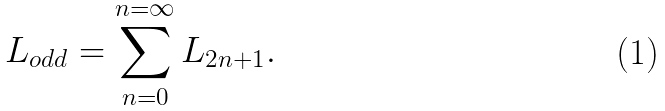Convert formula to latex. <formula><loc_0><loc_0><loc_500><loc_500>L _ { o d d } = \sum _ { n = 0 } ^ { n = \infty } L _ { 2 n + 1 } .</formula> 